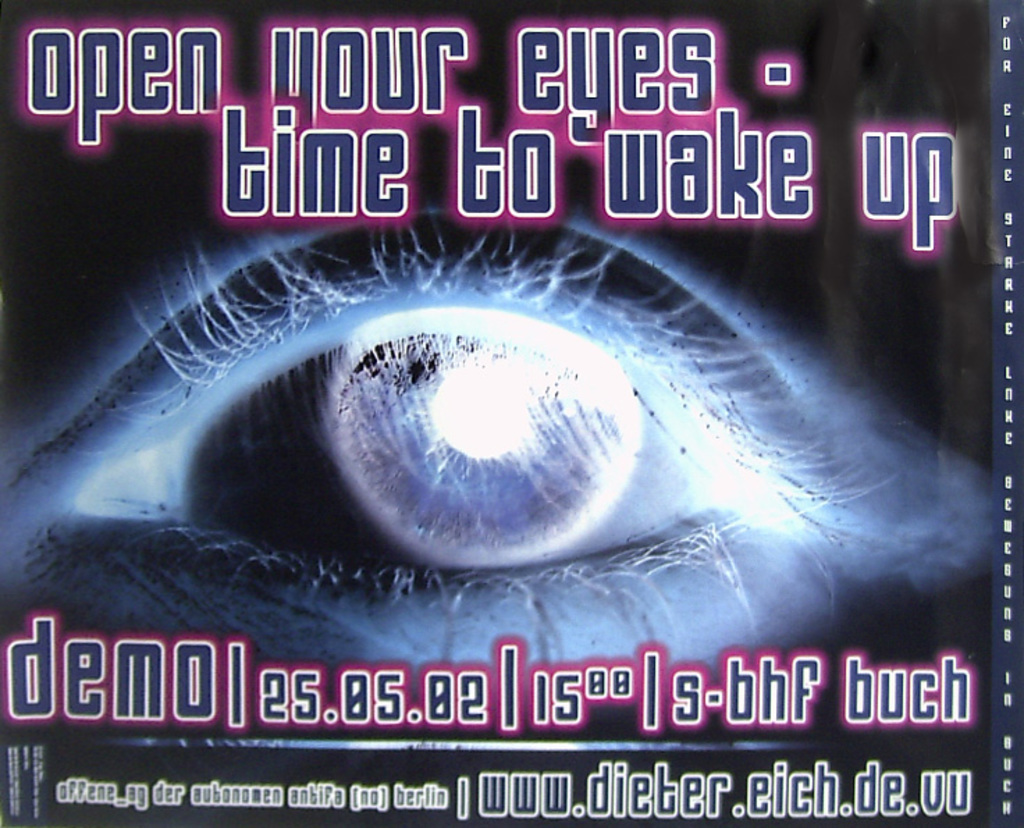Why did the designer choose such a dark and mysterious background for this poster? The dark, mysterious background sets a tone of intrigue and perhaps uncertainty. It contrasts sharply with the bright eye and neon text, emphasizing the theme of awakening from darkness or ignorance. This choice could be intended to attract viewers who are interested in stories or theories that explore deep, possibly unsettling truths, providing a visual metaphor for enlightenment emerging from darkness. Could the choice of colors have specific meanings? Absolutely, colors in visual media often carry symbolic meanings. The use of dark purples and blacks could represent the unknown or the unconscious, while the bright neon pink suggests energy, alertness, and modernity. This combination might be pointing to the contemporary relevance of the book’s themes, possibly appealing to a youthful, vibrant audience eager for change or new perspectives. 